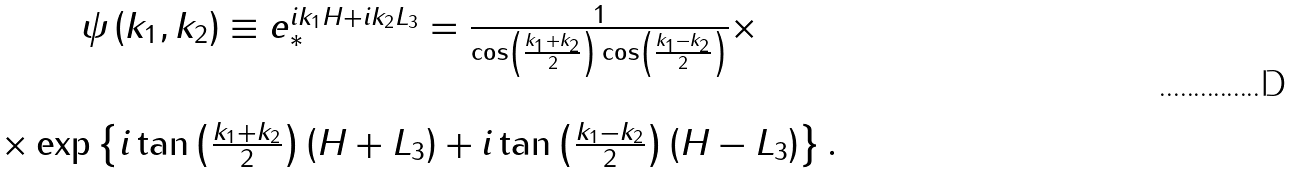<formula> <loc_0><loc_0><loc_500><loc_500>\begin{array} { c } \psi \left ( k _ { 1 } , k _ { 2 } \right ) \equiv e _ { * } ^ { i k _ { 1 } H + i k _ { 2 } L _ { 3 } } = \frac { 1 } { \cos \left ( \frac { k _ { 1 } + k _ { 2 } } { 2 } \right ) \cos \left ( \frac { k _ { 1 } - k _ { 2 } } { 2 } \right ) } \times \\ \\ \times \exp \left \{ i \tan \left ( \frac { k _ { 1 } + k _ { 2 } } { 2 } \right ) \left ( H + L _ { 3 } \right ) + i \tan \left ( \frac { k _ { 1 } - k _ { 2 } } { 2 } \right ) \left ( H - L _ { 3 } \right ) \right \} . \end{array}</formula> 